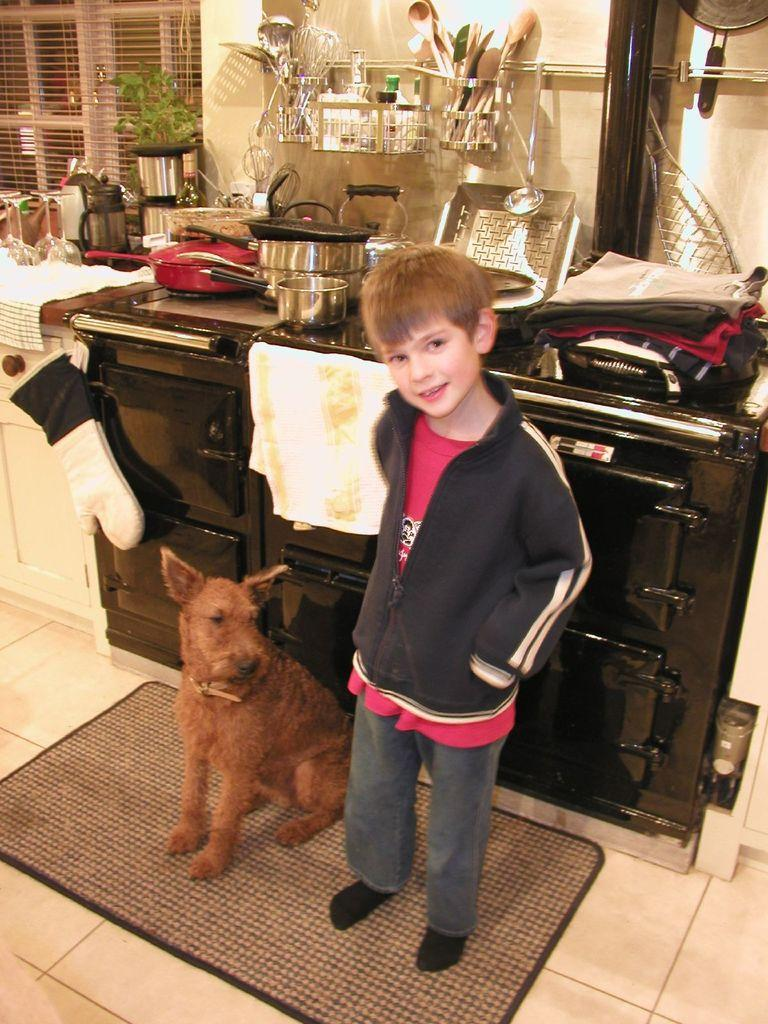What type of animal is in the image? There is a dog in the image. Who else is present in the image? There is a kid in the image. What is the kid wearing? The kid is wearing a jacket. Where are the kid and the dog standing? They are standing on a mat. What can be seen in the background of the image? There are utensils, objects on a surface, and a wall in the background of the image. How many people are in the crowd in the image? There is no crowd present in the image; it features a dog and a kid standing on a mat. What type of tooth is visible in the image? There is no tooth visible in the image. 